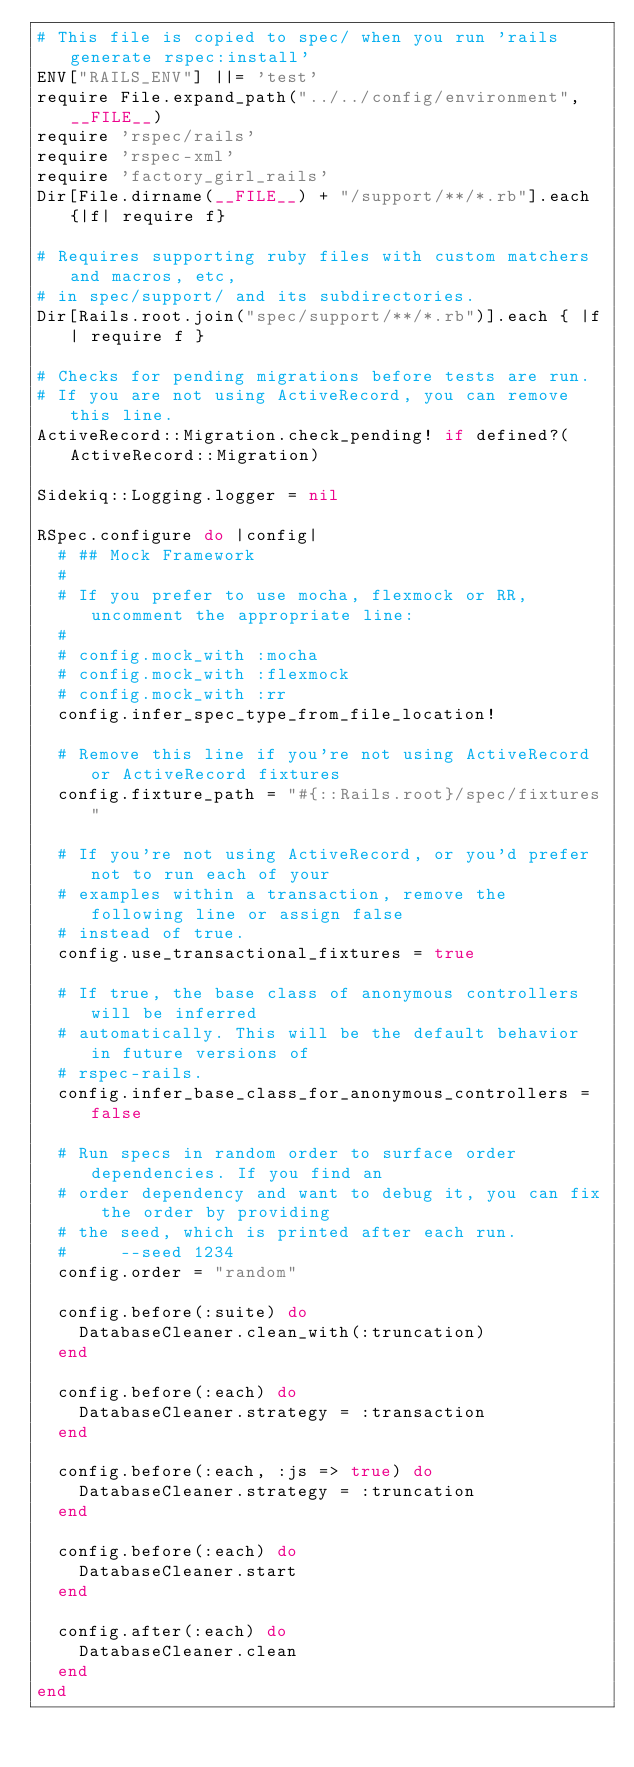Convert code to text. <code><loc_0><loc_0><loc_500><loc_500><_Ruby_># This file is copied to spec/ when you run 'rails generate rspec:install'
ENV["RAILS_ENV"] ||= 'test'
require File.expand_path("../../config/environment", __FILE__)
require 'rspec/rails'
require 'rspec-xml'
require 'factory_girl_rails'
Dir[File.dirname(__FILE__) + "/support/**/*.rb"].each {|f| require f}

# Requires supporting ruby files with custom matchers and macros, etc,
# in spec/support/ and its subdirectories.
Dir[Rails.root.join("spec/support/**/*.rb")].each { |f| require f }

# Checks for pending migrations before tests are run.
# If you are not using ActiveRecord, you can remove this line.
ActiveRecord::Migration.check_pending! if defined?(ActiveRecord::Migration)

Sidekiq::Logging.logger = nil

RSpec.configure do |config|
  # ## Mock Framework
  #
  # If you prefer to use mocha, flexmock or RR, uncomment the appropriate line:
  #
  # config.mock_with :mocha
  # config.mock_with :flexmock
  # config.mock_with :rr
  config.infer_spec_type_from_file_location!

  # Remove this line if you're not using ActiveRecord or ActiveRecord fixtures
  config.fixture_path = "#{::Rails.root}/spec/fixtures"

  # If you're not using ActiveRecord, or you'd prefer not to run each of your
  # examples within a transaction, remove the following line or assign false
  # instead of true.
  config.use_transactional_fixtures = true

  # If true, the base class of anonymous controllers will be inferred
  # automatically. This will be the default behavior in future versions of
  # rspec-rails.
  config.infer_base_class_for_anonymous_controllers = false

  # Run specs in random order to surface order dependencies. If you find an
  # order dependency and want to debug it, you can fix the order by providing
  # the seed, which is printed after each run.
  #     --seed 1234
  config.order = "random"

  config.before(:suite) do
    DatabaseCleaner.clean_with(:truncation)
  end

  config.before(:each) do
    DatabaseCleaner.strategy = :transaction
  end

  config.before(:each, :js => true) do
    DatabaseCleaner.strategy = :truncation
  end

  config.before(:each) do
    DatabaseCleaner.start
  end

  config.after(:each) do
    DatabaseCleaner.clean
  end
end
</code> 